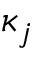<formula> <loc_0><loc_0><loc_500><loc_500>\kappa _ { j }</formula> 